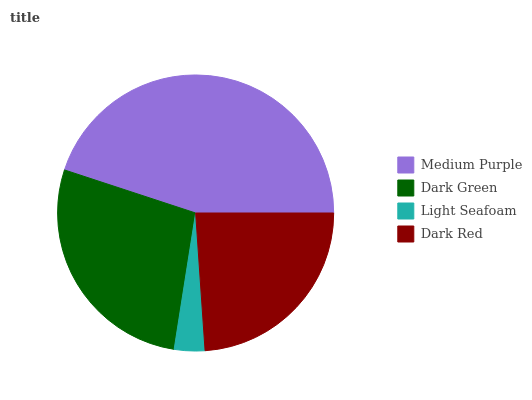Is Light Seafoam the minimum?
Answer yes or no. Yes. Is Medium Purple the maximum?
Answer yes or no. Yes. Is Dark Green the minimum?
Answer yes or no. No. Is Dark Green the maximum?
Answer yes or no. No. Is Medium Purple greater than Dark Green?
Answer yes or no. Yes. Is Dark Green less than Medium Purple?
Answer yes or no. Yes. Is Dark Green greater than Medium Purple?
Answer yes or no. No. Is Medium Purple less than Dark Green?
Answer yes or no. No. Is Dark Green the high median?
Answer yes or no. Yes. Is Dark Red the low median?
Answer yes or no. Yes. Is Light Seafoam the high median?
Answer yes or no. No. Is Medium Purple the low median?
Answer yes or no. No. 